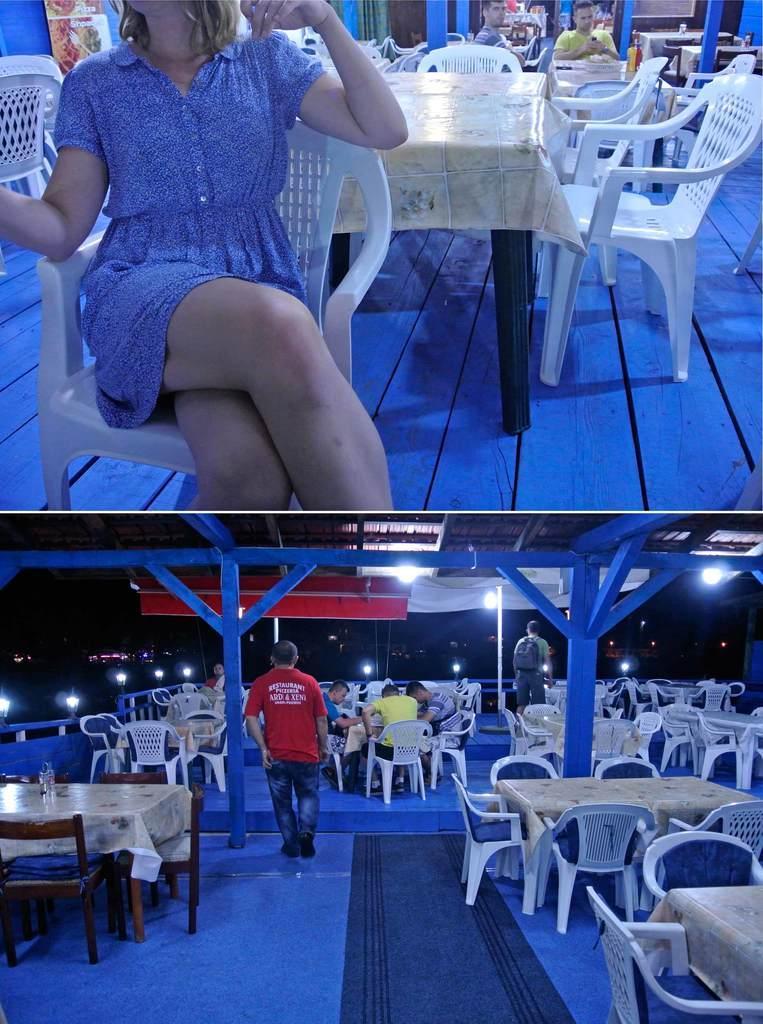In one or two sentences, can you explain what this image depicts? This is a collage. In this picture we can see a woman and two men sitting on the chair. There is a poster on the wall. We can see a few chairs and tables. In the bottom picture we can see a few people sitting on the chair. We can see a two men. There are few chairs and some tables. We can see a bottle on a table. 